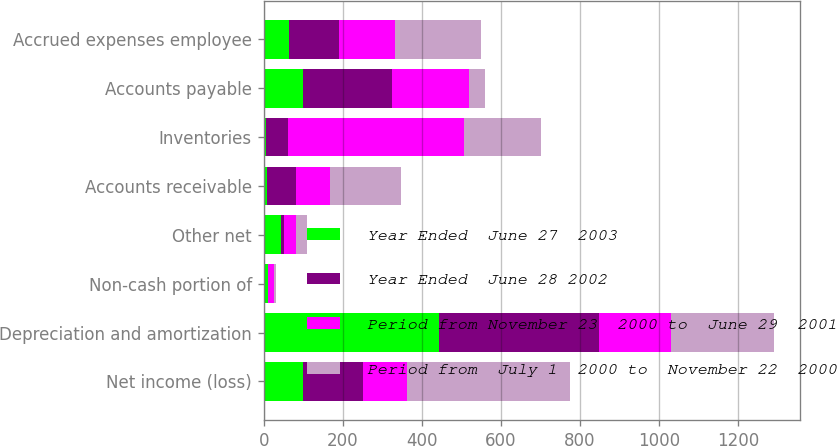<chart> <loc_0><loc_0><loc_500><loc_500><stacked_bar_chart><ecel><fcel>Net income (loss)<fcel>Depreciation and amortization<fcel>Non-cash portion of<fcel>Other net<fcel>Accounts receivable<fcel>Inventories<fcel>Accounts payable<fcel>Accrued expenses employee<nl><fcel>Year Ended  June 27  2003<fcel>99<fcel>443<fcel>10<fcel>44<fcel>8<fcel>5<fcel>99<fcel>63<nl><fcel>Year Ended  June 28 2002<fcel>153<fcel>405<fcel>1<fcel>8<fcel>75<fcel>57<fcel>225<fcel>128<nl><fcel>Period from November 23  2000 to  June 29  2001<fcel>110<fcel>182<fcel>14<fcel>31<fcel>84<fcel>444<fcel>196<fcel>141<nl><fcel>Period from  July 1  2000 to  November 22  2000<fcel>412<fcel>261<fcel>7<fcel>27<fcel>181<fcel>195<fcel>40<fcel>218<nl></chart> 